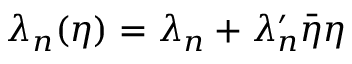<formula> <loc_0><loc_0><loc_500><loc_500>\lambda _ { n } ( \eta ) = \lambda _ { n } + \lambda _ { n } ^ { \prime } \bar { \eta } \eta</formula> 